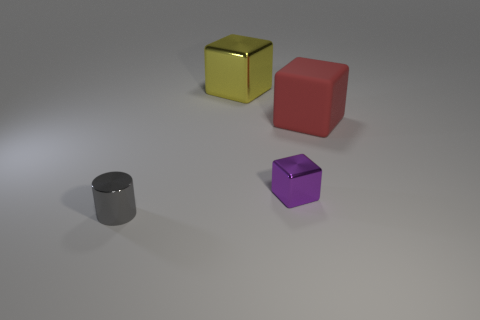Subtract all big blocks. How many blocks are left? 1 Add 1 red things. How many objects exist? 5 Subtract all purple blocks. How many blocks are left? 2 Subtract 1 blocks. How many blocks are left? 2 Subtract 0 cyan cylinders. How many objects are left? 4 Subtract all cylinders. How many objects are left? 3 Subtract all yellow blocks. Subtract all green balls. How many blocks are left? 2 Subtract all yellow balls. How many yellow cylinders are left? 0 Subtract all small green balls. Subtract all large blocks. How many objects are left? 2 Add 1 large yellow cubes. How many large yellow cubes are left? 2 